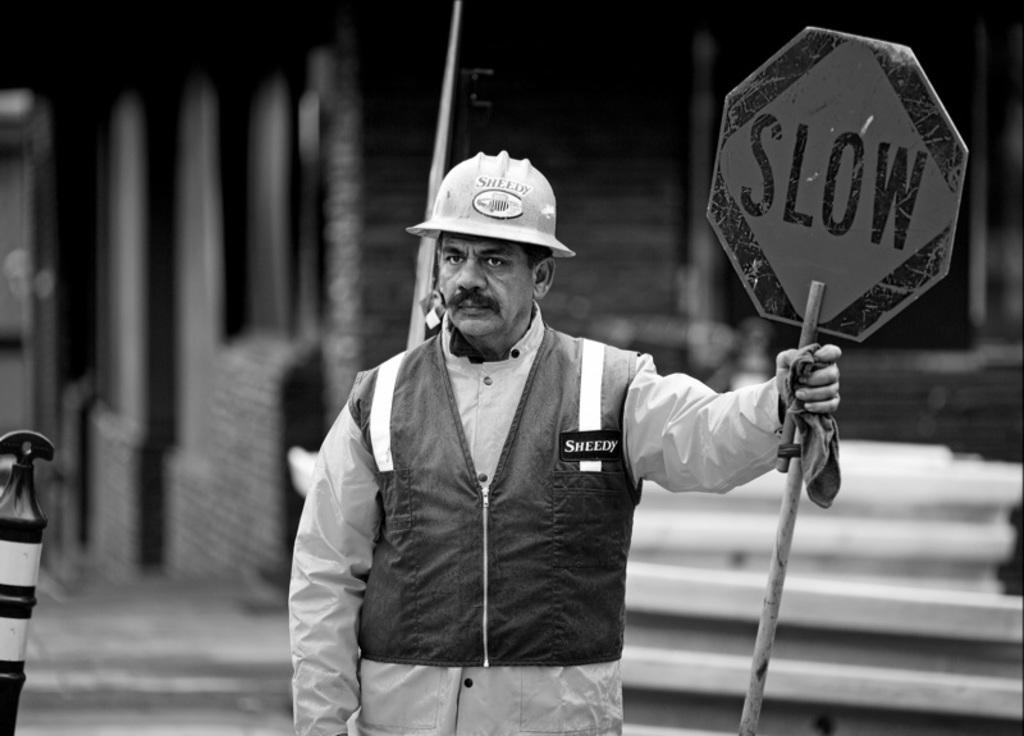Please provide a concise description of this image. In the picture there is a man standing and watching a pole with the board, behind the man there may be a house present. 